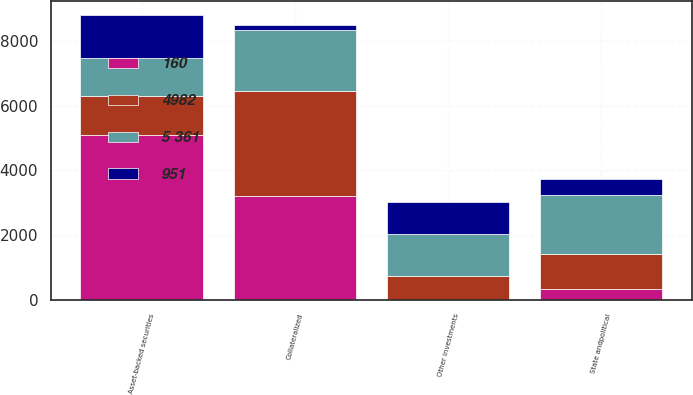Convert chart. <chart><loc_0><loc_0><loc_500><loc_500><stacked_bar_chart><ecel><fcel>Asset-backed securities<fcel>Collateralized<fcel>State andpolitical<fcel>Other investments<nl><fcel>951<fcel>1324<fcel>142<fcel>500<fcel>996<nl><fcel>5 361<fcel>1181<fcel>1892<fcel>1828<fcel>1285<nl><fcel>4982<fcel>1181<fcel>3231<fcel>1077<fcel>731<nl><fcel>160<fcel>5104<fcel>3211<fcel>344<fcel>15<nl></chart> 